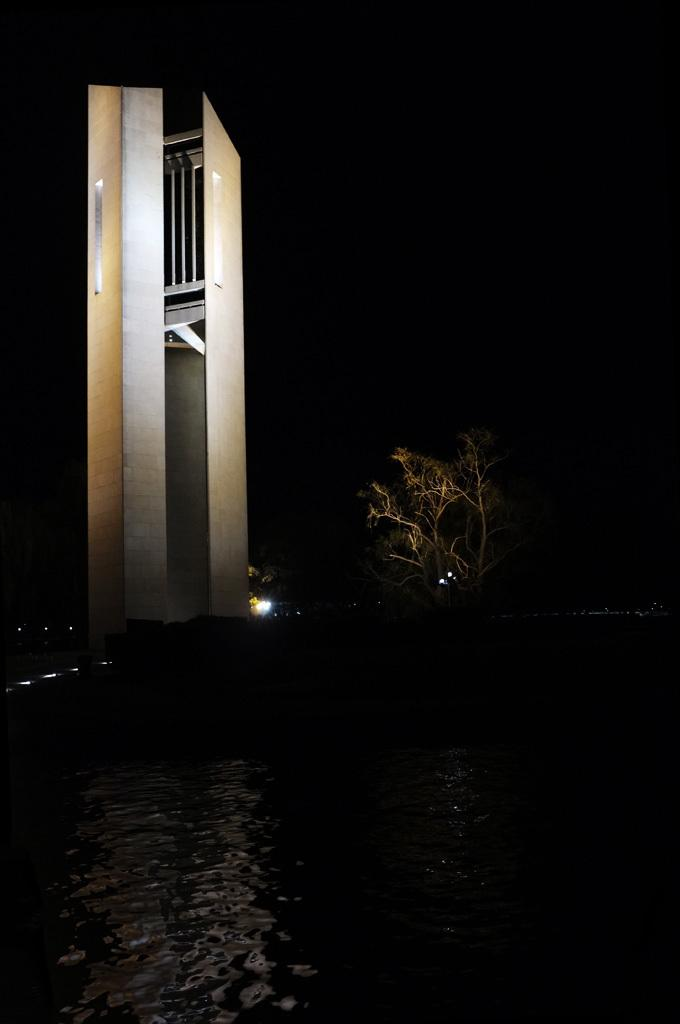What is the main structure in the image? There is a tower in the image. What type of natural elements can be seen in the image? There are trees visible in the image. What can be seen illuminating the scene in the image? There are lights in the image. What is present at the bottom of the image? There is water at the bottom of the image. What type of committee is meeting in the bedroom in the image? There is no bedroom or committee present in the image. How many cameras can be seen in the image? There are no cameras present in the image. 